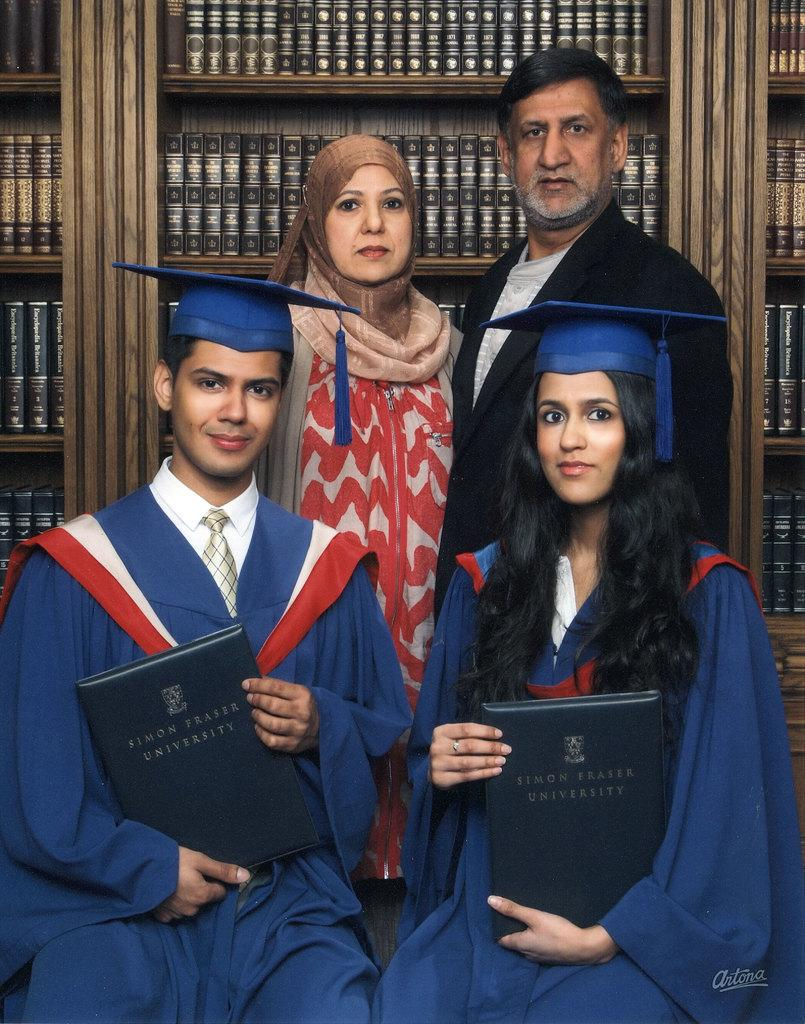How many people are in the image? There are four people in the image. What are two of the people doing in the image? Two of the people are sitting. What are the sitting people holding? The sitting people are holding books. What can be seen behind the people in the image? There are cracks filled with books behind the people. What type of honey is being used to hold the books together in the image? There is no honey present in the image, and the books are not being held together by any substance. 